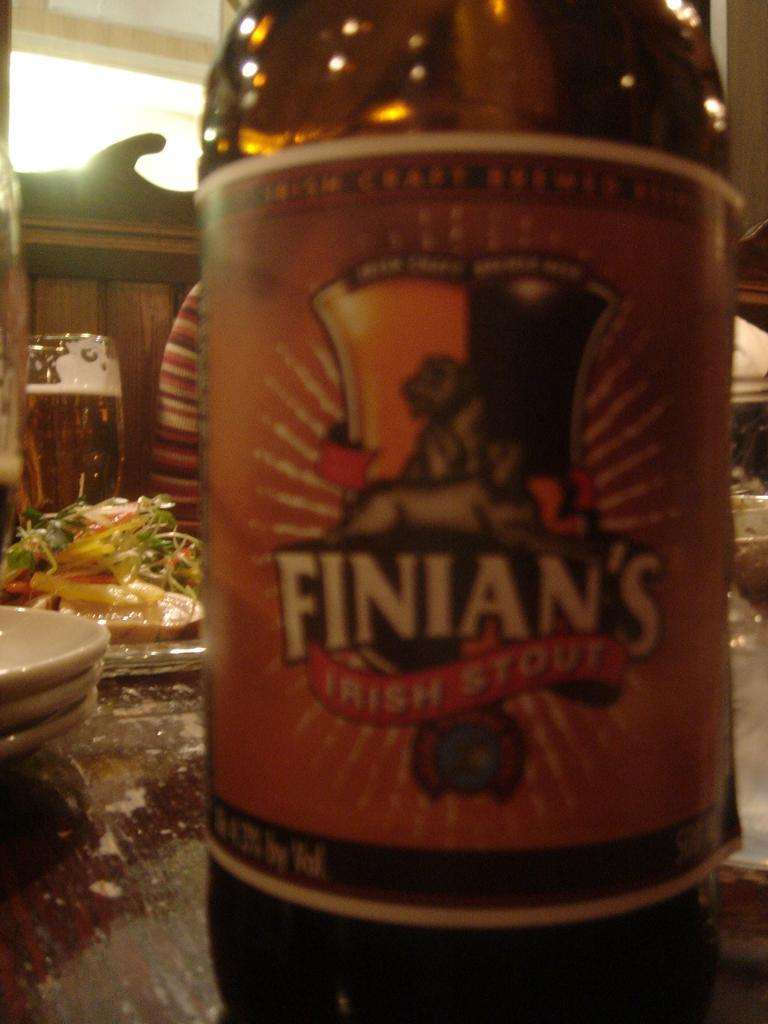<image>
Offer a succinct explanation of the picture presented. The label of Finian's stout beer is shown up close. 